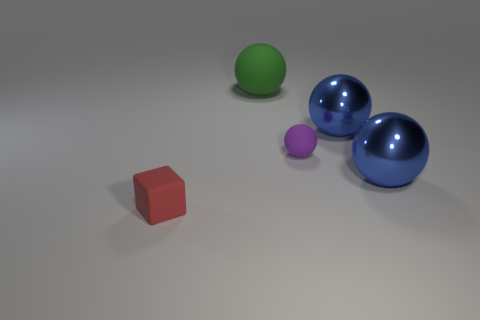Subtract all green matte balls. How many balls are left? 3 Subtract all green balls. How many balls are left? 3 Add 2 big green balls. How many objects exist? 7 Subtract 0 purple cubes. How many objects are left? 5 Subtract all blocks. How many objects are left? 4 Subtract 1 cubes. How many cubes are left? 0 Subtract all purple blocks. Subtract all purple cylinders. How many blocks are left? 1 Subtract all yellow cubes. How many purple balls are left? 1 Subtract all purple balls. Subtract all metal things. How many objects are left? 2 Add 1 tiny objects. How many tiny objects are left? 3 